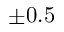<formula> <loc_0><loc_0><loc_500><loc_500>\pm 0 . 5</formula> 